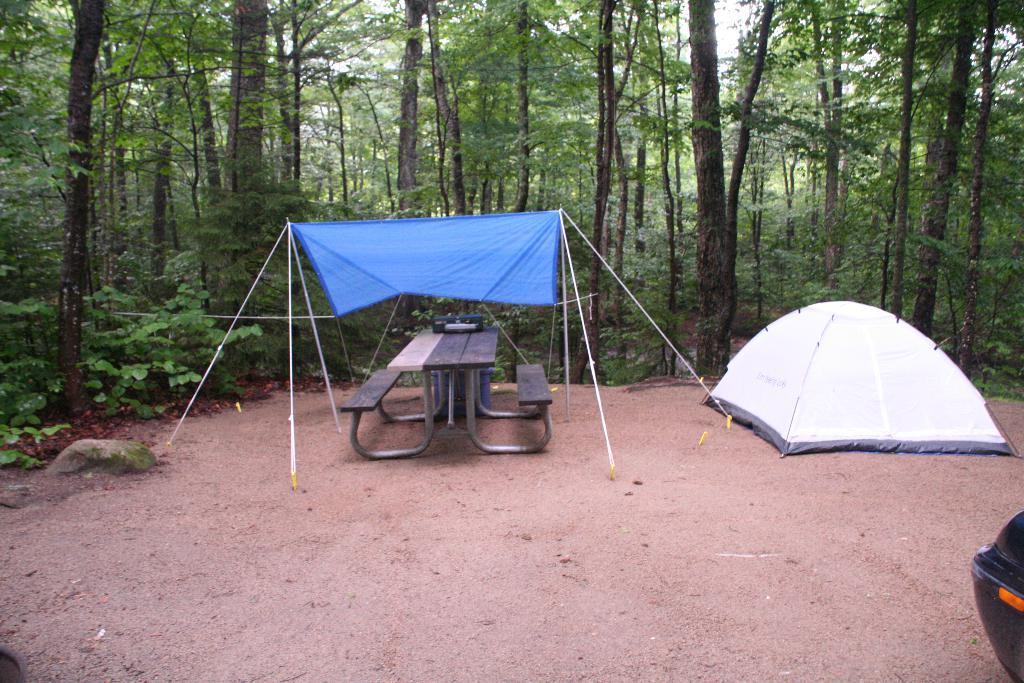What can be seen in the foreground of the picture? In the foreground of the picture, there are tents, a bench, soil, and other objects. Can you describe the objects in the foreground? The objects in the foreground include tents and a bench. What is visible in the background of the picture? In the background of the picture, there are plants, trees, and the sky. How many types of vegetation can be seen in the background? Two types of vegetation can be seen in the background: plants and trees. Who is teaching the class in the picture? There is no class or teaching activity depicted in the image. What type of powder is being used to create the tents in the picture? There is no powder mentioned or visible in the image; the tents are likely made of fabric or other materials. 